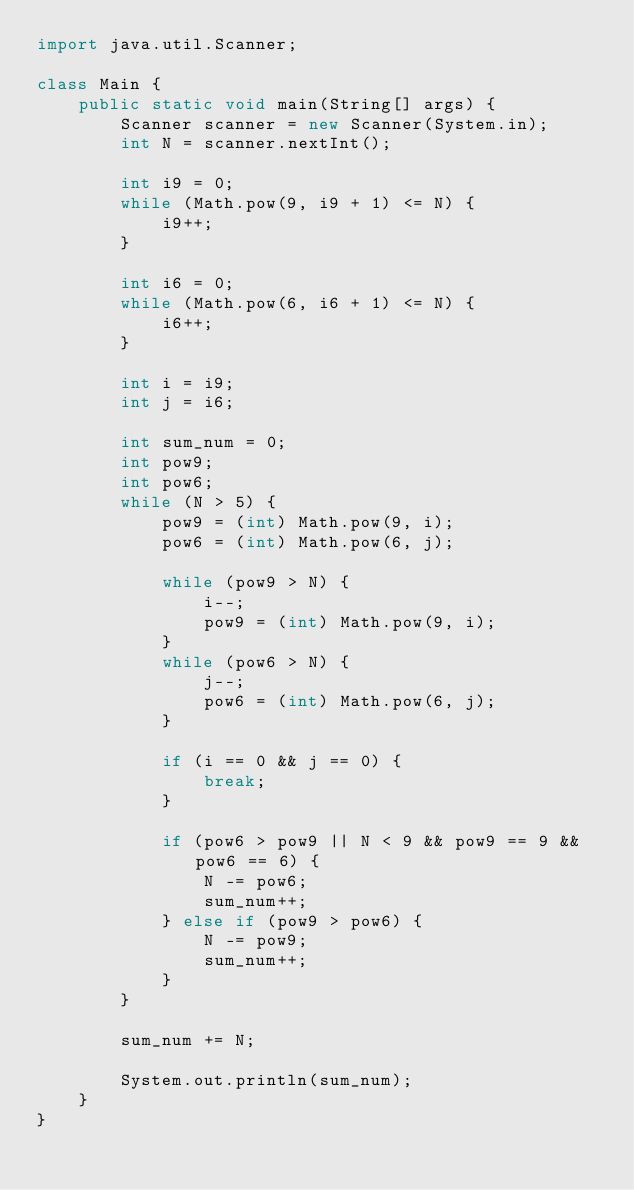Convert code to text. <code><loc_0><loc_0><loc_500><loc_500><_Java_>import java.util.Scanner;

class Main {
    public static void main(String[] args) {
        Scanner scanner = new Scanner(System.in);
        int N = scanner.nextInt();

        int i9 = 0;
        while (Math.pow(9, i9 + 1) <= N) {
            i9++;
        }

        int i6 = 0;
        while (Math.pow(6, i6 + 1) <= N) {
            i6++;
        }

        int i = i9;
        int j = i6;

        int sum_num = 0;
        int pow9;
        int pow6;
        while (N > 5) {
            pow9 = (int) Math.pow(9, i);
            pow6 = (int) Math.pow(6, j);

            while (pow9 > N) {
                i--;
                pow9 = (int) Math.pow(9, i);
            }
            while (pow6 > N) {
                j--;
                pow6 = (int) Math.pow(6, j);
            }

            if (i == 0 && j == 0) {
                break;
            }

            if (pow6 > pow9 || N < 9 && pow9 == 9 && pow6 == 6) {
                N -= pow6;
                sum_num++;
            } else if (pow9 > pow6) {
                N -= pow9;
                sum_num++;
            }
        }

        sum_num += N;

        System.out.println(sum_num);
    }
}
</code> 